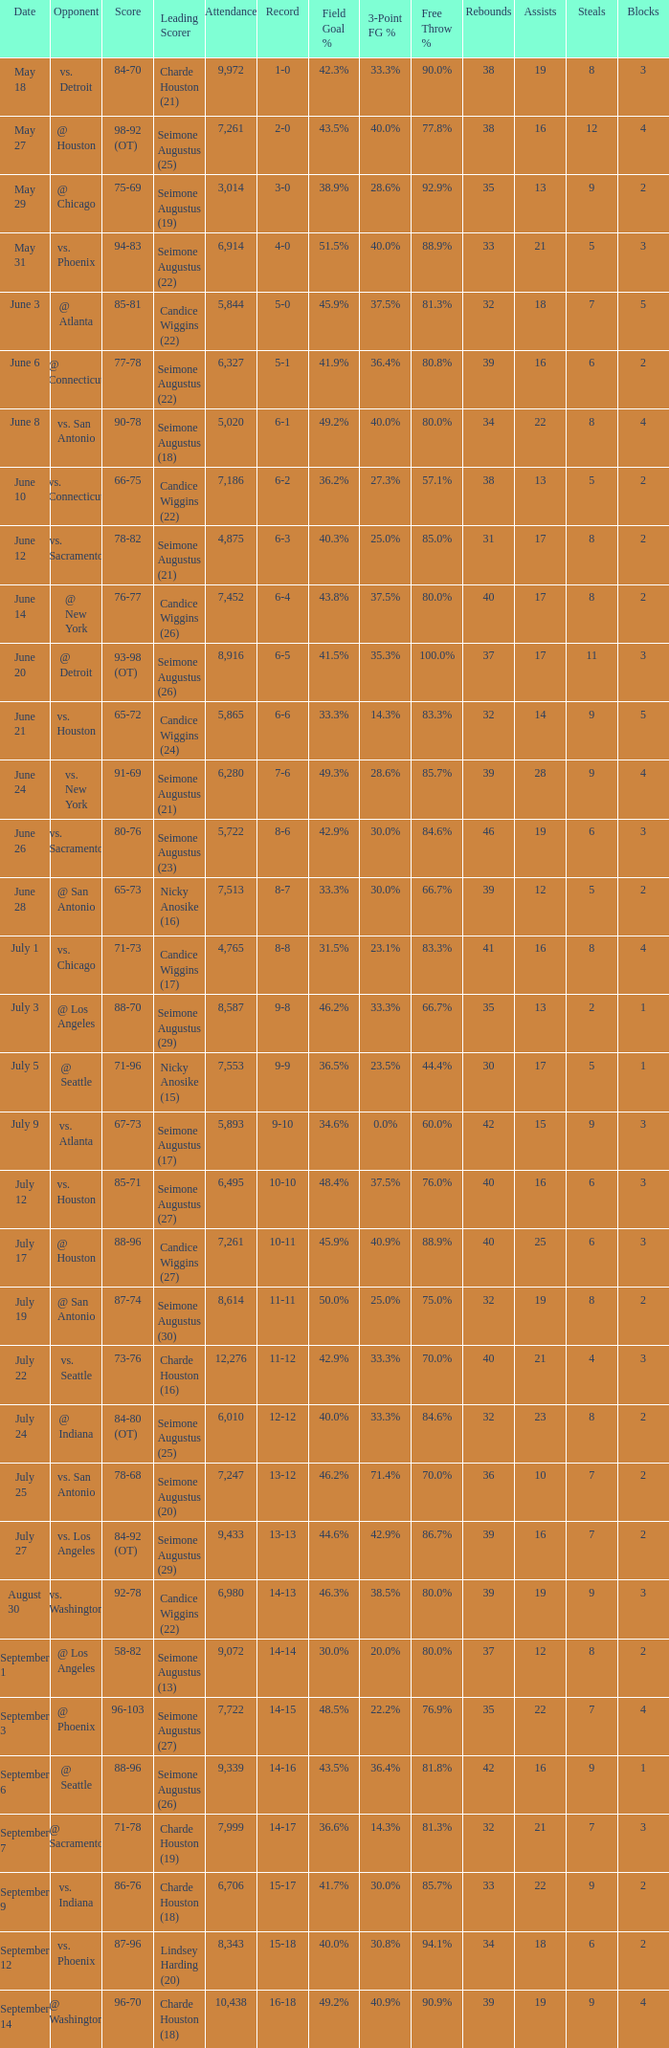Which Score has an Opponent of @ houston, and a Record of 2-0? 98-92 (OT). 